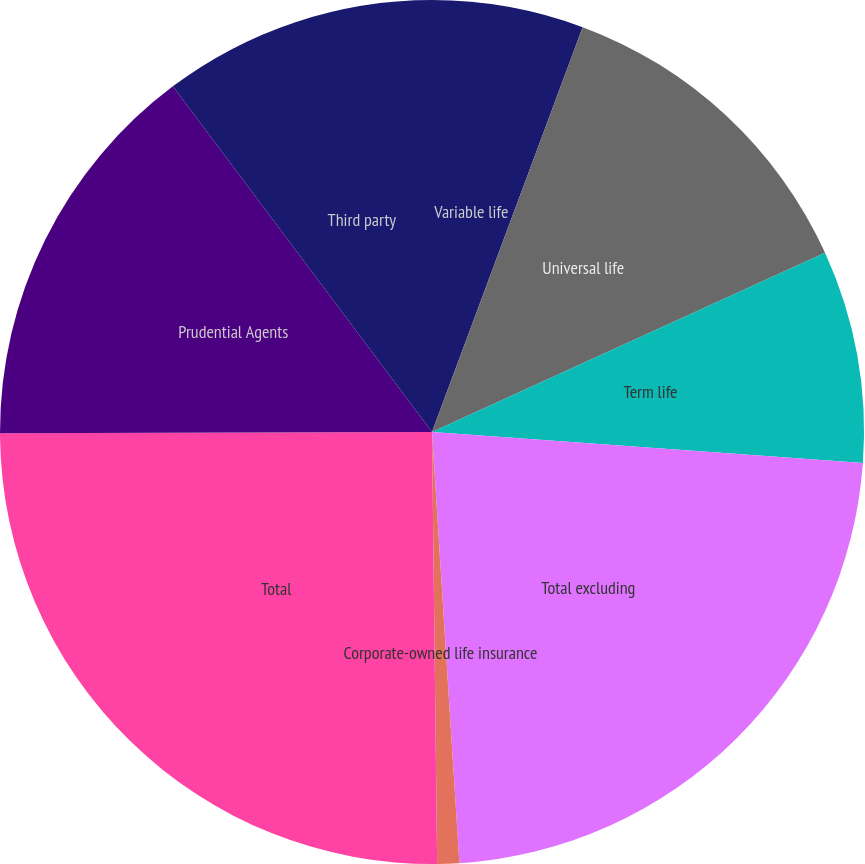Convert chart to OTSL. <chart><loc_0><loc_0><loc_500><loc_500><pie_chart><fcel>Variable life<fcel>Universal life<fcel>Term life<fcel>Total excluding<fcel>Corporate-owned life insurance<fcel>Total<fcel>Prudential Agents<fcel>Third party<nl><fcel>5.67%<fcel>12.52%<fcel>7.95%<fcel>22.85%<fcel>0.82%<fcel>25.14%<fcel>14.81%<fcel>10.24%<nl></chart> 